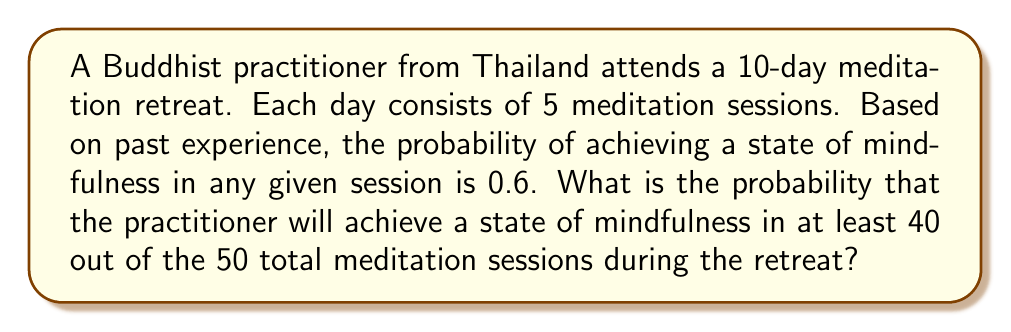Give your solution to this math problem. To solve this problem, we can use the binomial probability distribution. Let's break it down step-by-step:

1) We have 50 independent trials (meditation sessions), each with a probability of success (achieving mindfulness) of 0.6.

2) We want to find the probability of 40 or more successes out of 50 trials.

3) The probability of exactly $k$ successes in $n$ trials is given by the binomial probability formula:

   $$P(X = k) = \binom{n}{k} p^k (1-p)^{n-k}$$

   where $n$ is the number of trials, $k$ is the number of successes, $p$ is the probability of success on each trial.

4) We need to sum this probability for $k = 40, 41, 42, ..., 50$:

   $$P(X \geq 40) = \sum_{k=40}^{50} \binom{50}{k} (0.6)^k (0.4)^{50-k}$$

5) This can be calculated using the cumulative binomial probability function, which is available in most statistical software or can be approximated using the normal distribution for large $n$.

6) Using a calculator or computer program, we can compute this sum:

   $$P(X \geq 40) \approx 0.0442$$

Therefore, the probability of achieving a state of mindfulness in at least 40 out of 50 meditation sessions is approximately 0.0442 or 4.42%.
Answer: The probability is approximately 0.0442 or 4.42%. 